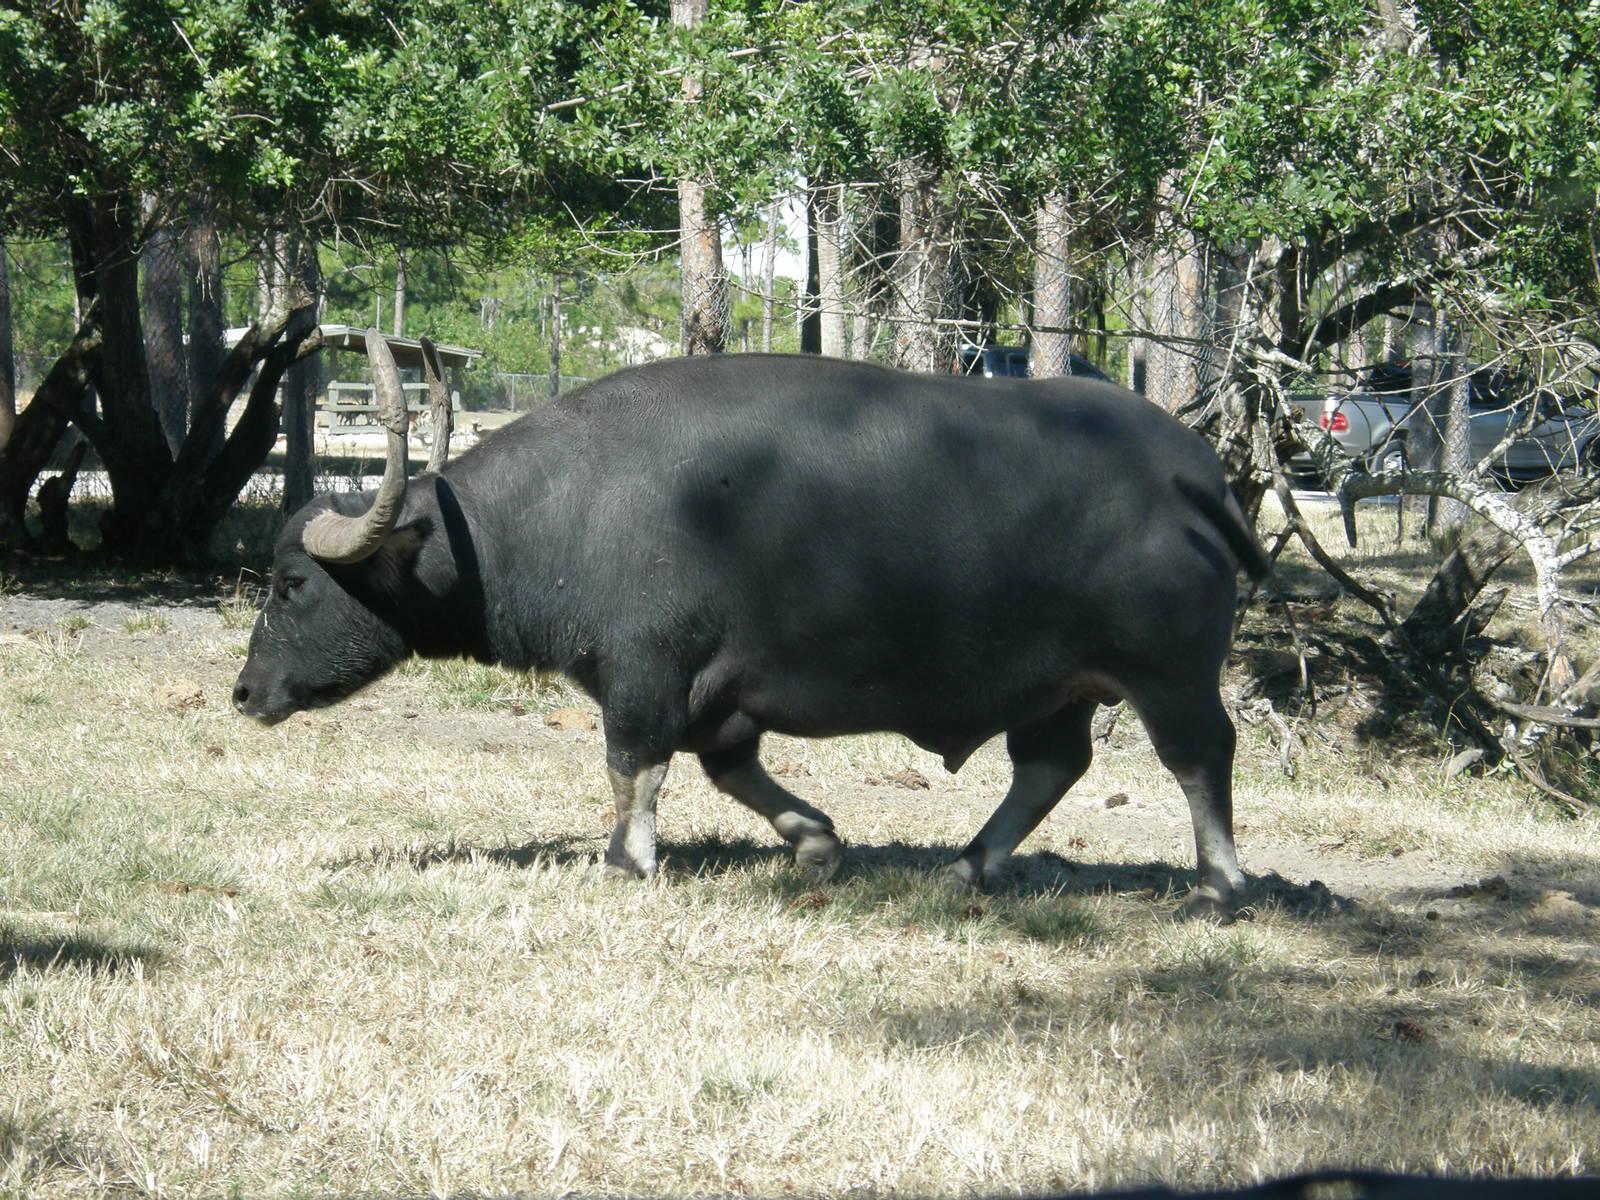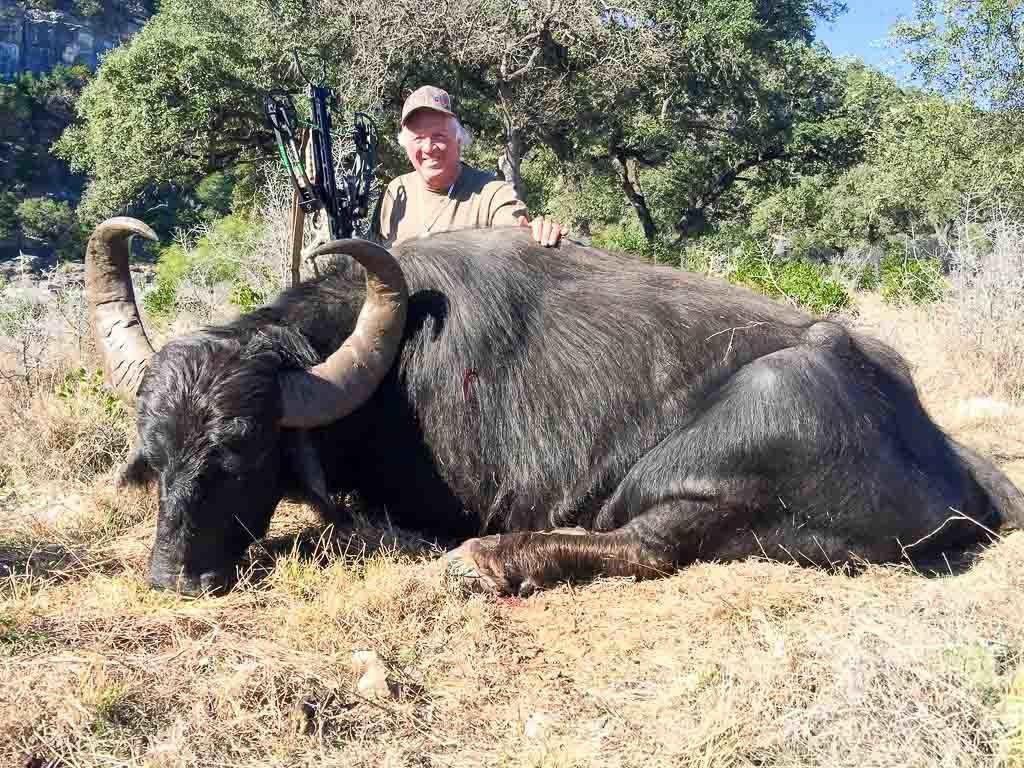The first image is the image on the left, the second image is the image on the right. Considering the images on both sides, is "An image shows one water buffalo standing in water that does not reach its chest." valid? Answer yes or no. No. The first image is the image on the left, the second image is the image on the right. Assess this claim about the two images: "An image contains a water buffalo standing on water.". Correct or not? Answer yes or no. No. 